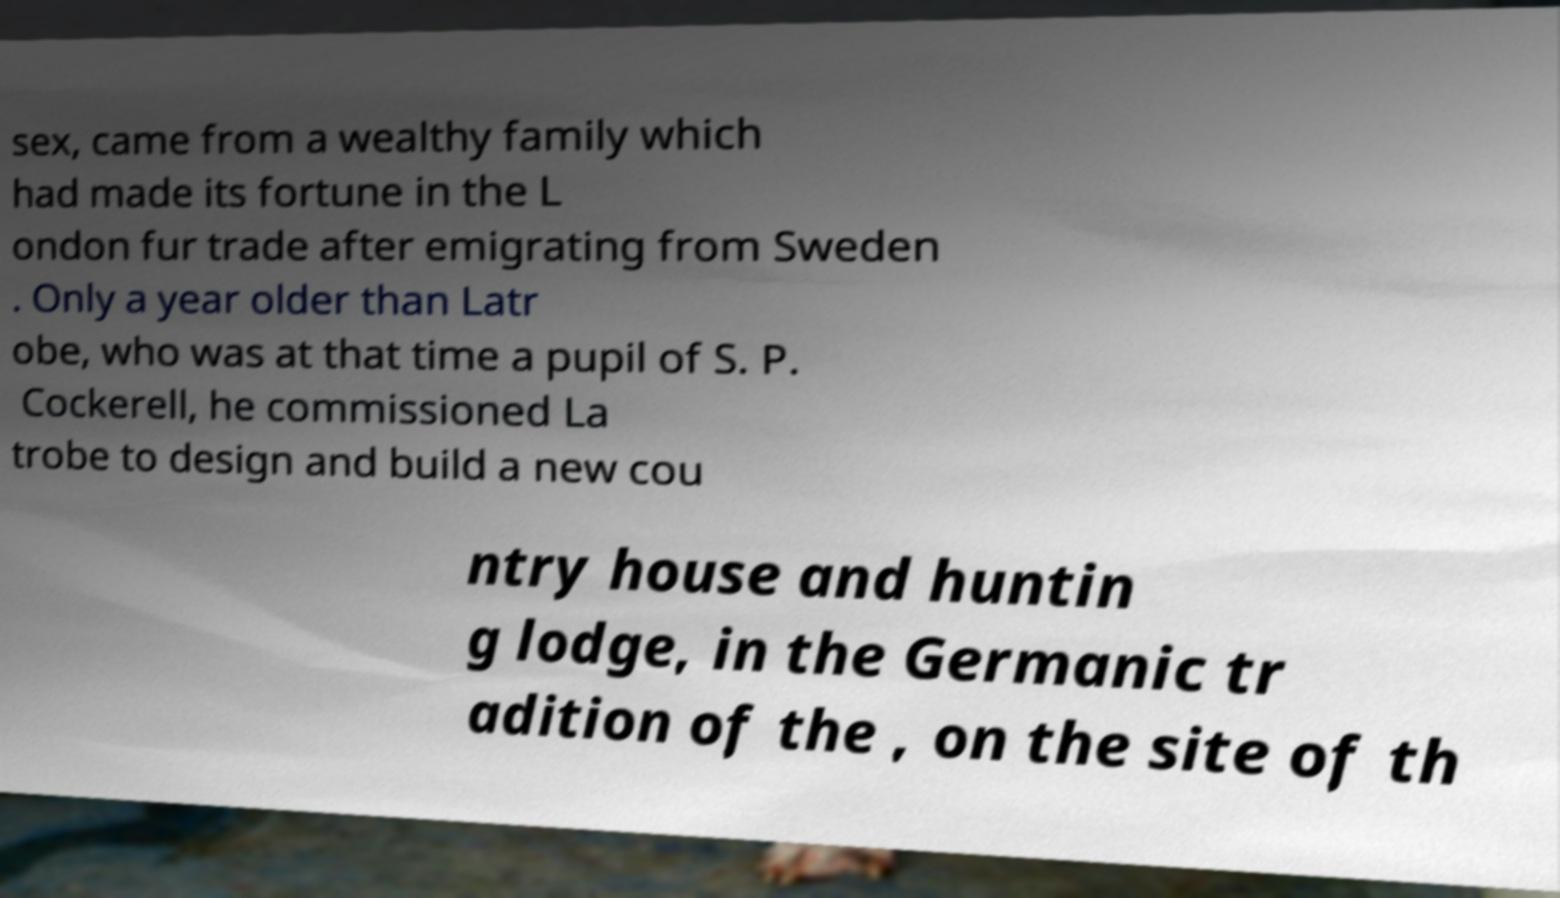There's text embedded in this image that I need extracted. Can you transcribe it verbatim? sex, came from a wealthy family which had made its fortune in the L ondon fur trade after emigrating from Sweden . Only a year older than Latr obe, who was at that time a pupil of S. P. Cockerell, he commissioned La trobe to design and build a new cou ntry house and huntin g lodge, in the Germanic tr adition of the , on the site of th 